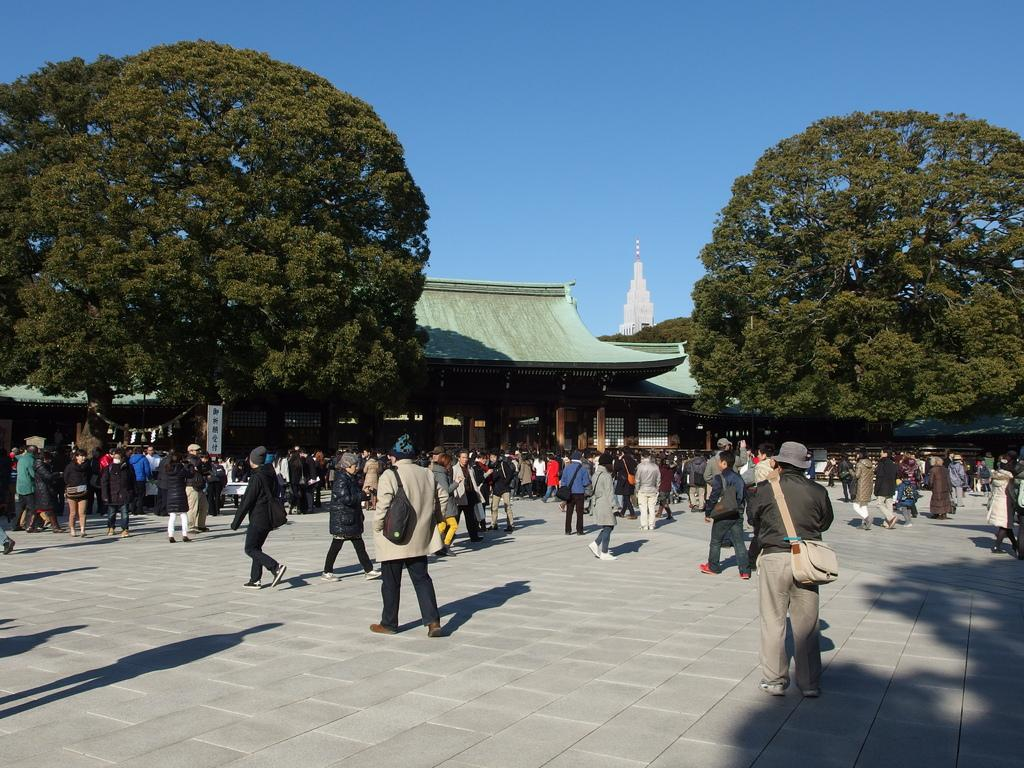What are the people in the image doing? The people in the image are standing and walking. What are the people holding in the image? The people are holding bags. What can be seen in the background of the image? There are trees and buildings visible in the background of the image. What is visible at the top of the image? The sky is visible at the top of the image. Can you see a twig in the mouth of any person in the image? There is no twig visible in the mouth of any person in the image. Is there a family gathering taking place in the image? The image does not provide any information about a family gathering or the relationships between the people present. 